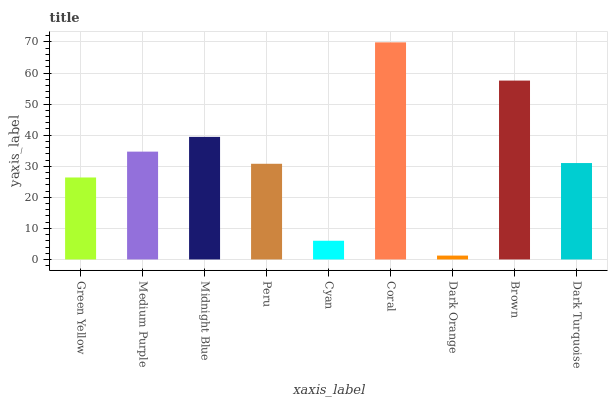Is Dark Orange the minimum?
Answer yes or no. Yes. Is Coral the maximum?
Answer yes or no. Yes. Is Medium Purple the minimum?
Answer yes or no. No. Is Medium Purple the maximum?
Answer yes or no. No. Is Medium Purple greater than Green Yellow?
Answer yes or no. Yes. Is Green Yellow less than Medium Purple?
Answer yes or no. Yes. Is Green Yellow greater than Medium Purple?
Answer yes or no. No. Is Medium Purple less than Green Yellow?
Answer yes or no. No. Is Dark Turquoise the high median?
Answer yes or no. Yes. Is Dark Turquoise the low median?
Answer yes or no. Yes. Is Green Yellow the high median?
Answer yes or no. No. Is Coral the low median?
Answer yes or no. No. 